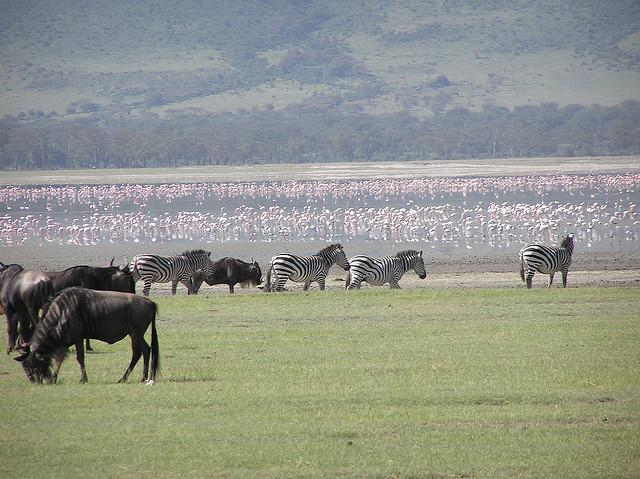Which animal is the weakest? zebra 